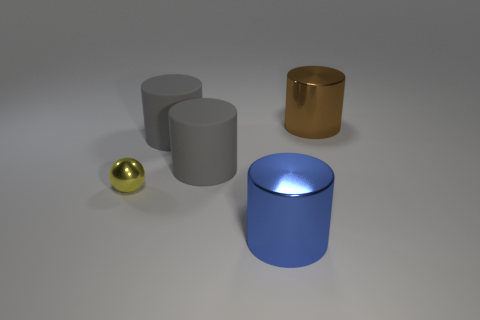Subtract all balls. How many objects are left? 4 Add 3 tiny objects. How many objects exist? 8 Add 3 small things. How many small things are left? 4 Add 3 big blue metal cylinders. How many big blue metal cylinders exist? 4 Subtract 0 purple blocks. How many objects are left? 5 Subtract all large blue metal cylinders. Subtract all red metal cubes. How many objects are left? 4 